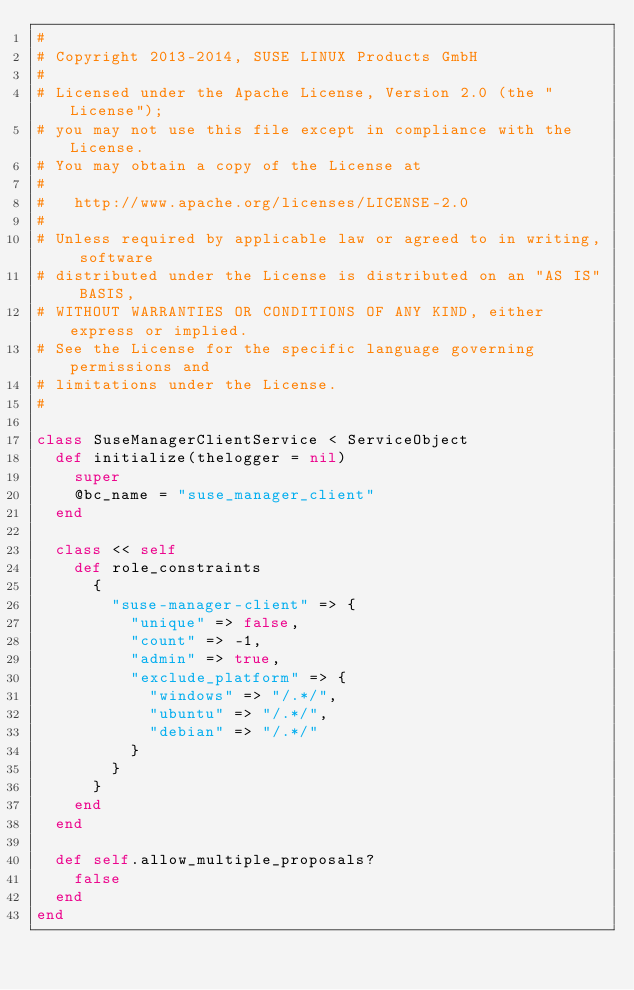<code> <loc_0><loc_0><loc_500><loc_500><_Ruby_>#
# Copyright 2013-2014, SUSE LINUX Products GmbH
#
# Licensed under the Apache License, Version 2.0 (the "License");
# you may not use this file except in compliance with the License.
# You may obtain a copy of the License at
#
#   http://www.apache.org/licenses/LICENSE-2.0
#
# Unless required by applicable law or agreed to in writing, software
# distributed under the License is distributed on an "AS IS" BASIS,
# WITHOUT WARRANTIES OR CONDITIONS OF ANY KIND, either express or implied.
# See the License for the specific language governing permissions and
# limitations under the License.
#

class SuseManagerClientService < ServiceObject
  def initialize(thelogger = nil)
    super
    @bc_name = "suse_manager_client"
  end

  class << self
    def role_constraints
      {
        "suse-manager-client" => {
          "unique" => false,
          "count" => -1,
          "admin" => true,
          "exclude_platform" => {
            "windows" => "/.*/",
            "ubuntu" => "/.*/",
            "debian" => "/.*/"
          }
        }
      }
    end
  end

  def self.allow_multiple_proposals?
    false
  end
end
</code> 